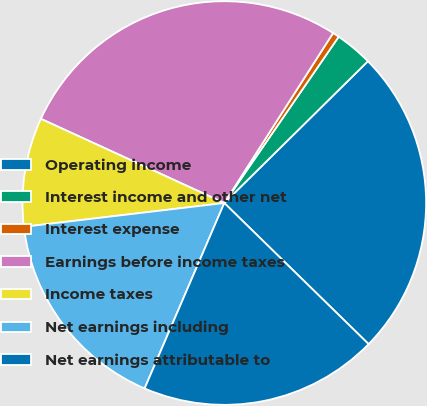Convert chart. <chart><loc_0><loc_0><loc_500><loc_500><pie_chart><fcel>Operating income<fcel>Interest income and other net<fcel>Interest expense<fcel>Earnings before income taxes<fcel>Income taxes<fcel>Net earnings including<fcel>Net earnings attributable to<nl><fcel>24.72%<fcel>3.01%<fcel>0.53%<fcel>27.21%<fcel>8.73%<fcel>16.66%<fcel>19.14%<nl></chart> 